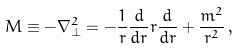Convert formula to latex. <formula><loc_0><loc_0><loc_500><loc_500>M \equiv - \nabla _ { \perp } ^ { 2 } = - \frac { 1 } { r } \frac { d } { d r } r \frac { d } { d r } + \frac { m ^ { 2 } } { r ^ { 2 } } \, ,</formula> 